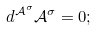Convert formula to latex. <formula><loc_0><loc_0><loc_500><loc_500>d ^ { \mathcal { A } ^ { \sigma } } \mathcal { A } ^ { \sigma } = 0 ;</formula> 